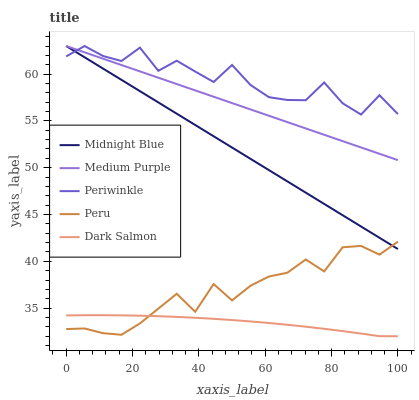Does Dark Salmon have the minimum area under the curve?
Answer yes or no. Yes. Does Periwinkle have the maximum area under the curve?
Answer yes or no. Yes. Does Midnight Blue have the minimum area under the curve?
Answer yes or no. No. Does Midnight Blue have the maximum area under the curve?
Answer yes or no. No. Is Midnight Blue the smoothest?
Answer yes or no. Yes. Is Periwinkle the roughest?
Answer yes or no. Yes. Is Periwinkle the smoothest?
Answer yes or no. No. Is Midnight Blue the roughest?
Answer yes or no. No. Does Dark Salmon have the lowest value?
Answer yes or no. Yes. Does Midnight Blue have the lowest value?
Answer yes or no. No. Does Midnight Blue have the highest value?
Answer yes or no. Yes. Does Peru have the highest value?
Answer yes or no. No. Is Dark Salmon less than Midnight Blue?
Answer yes or no. Yes. Is Medium Purple greater than Dark Salmon?
Answer yes or no. Yes. Does Midnight Blue intersect Periwinkle?
Answer yes or no. Yes. Is Midnight Blue less than Periwinkle?
Answer yes or no. No. Is Midnight Blue greater than Periwinkle?
Answer yes or no. No. Does Dark Salmon intersect Midnight Blue?
Answer yes or no. No. 